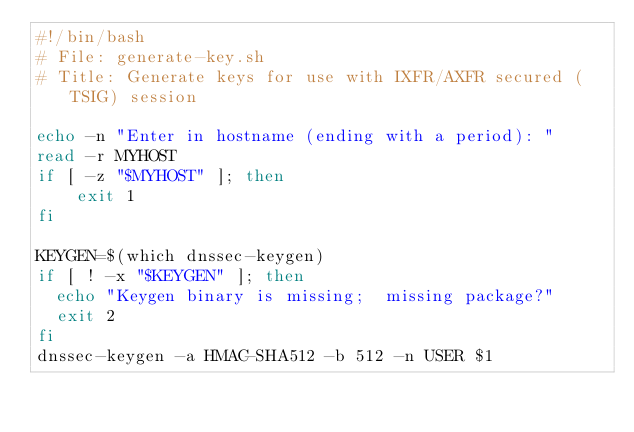Convert code to text. <code><loc_0><loc_0><loc_500><loc_500><_Bash_>#!/bin/bash
# File: generate-key.sh
# Title: Generate keys for use with IXFR/AXFR secured (TSIG) session

echo -n "Enter in hostname (ending with a period): "
read -r MYHOST
if [ -z "$MYHOST" ]; then
    exit 1
fi

KEYGEN=$(which dnssec-keygen)
if [ ! -x "$KEYGEN" ]; then
  echo "Keygen binary is missing;  missing package?"
  exit 2
fi
dnssec-keygen -a HMAC-SHA512 -b 512 -n USER $1
</code> 